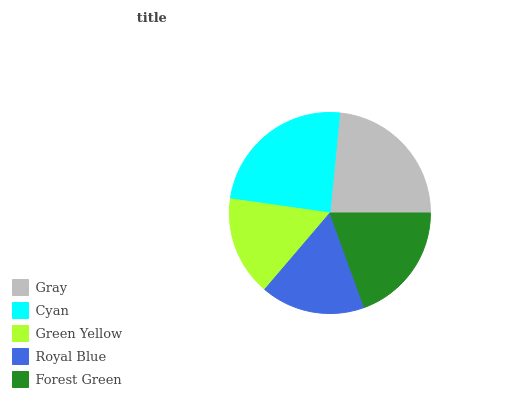Is Green Yellow the minimum?
Answer yes or no. Yes. Is Cyan the maximum?
Answer yes or no. Yes. Is Cyan the minimum?
Answer yes or no. No. Is Green Yellow the maximum?
Answer yes or no. No. Is Cyan greater than Green Yellow?
Answer yes or no. Yes. Is Green Yellow less than Cyan?
Answer yes or no. Yes. Is Green Yellow greater than Cyan?
Answer yes or no. No. Is Cyan less than Green Yellow?
Answer yes or no. No. Is Forest Green the high median?
Answer yes or no. Yes. Is Forest Green the low median?
Answer yes or no. Yes. Is Gray the high median?
Answer yes or no. No. Is Cyan the low median?
Answer yes or no. No. 